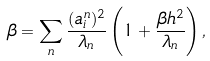Convert formula to latex. <formula><loc_0><loc_0><loc_500><loc_500>\beta & = \sum _ { n } \frac { ( a ^ { n } _ { i } ) ^ { 2 } } { \lambda _ { n } } \left ( 1 + \frac { \beta h ^ { 2 } } { \lambda _ { n } } \right ) ,</formula> 